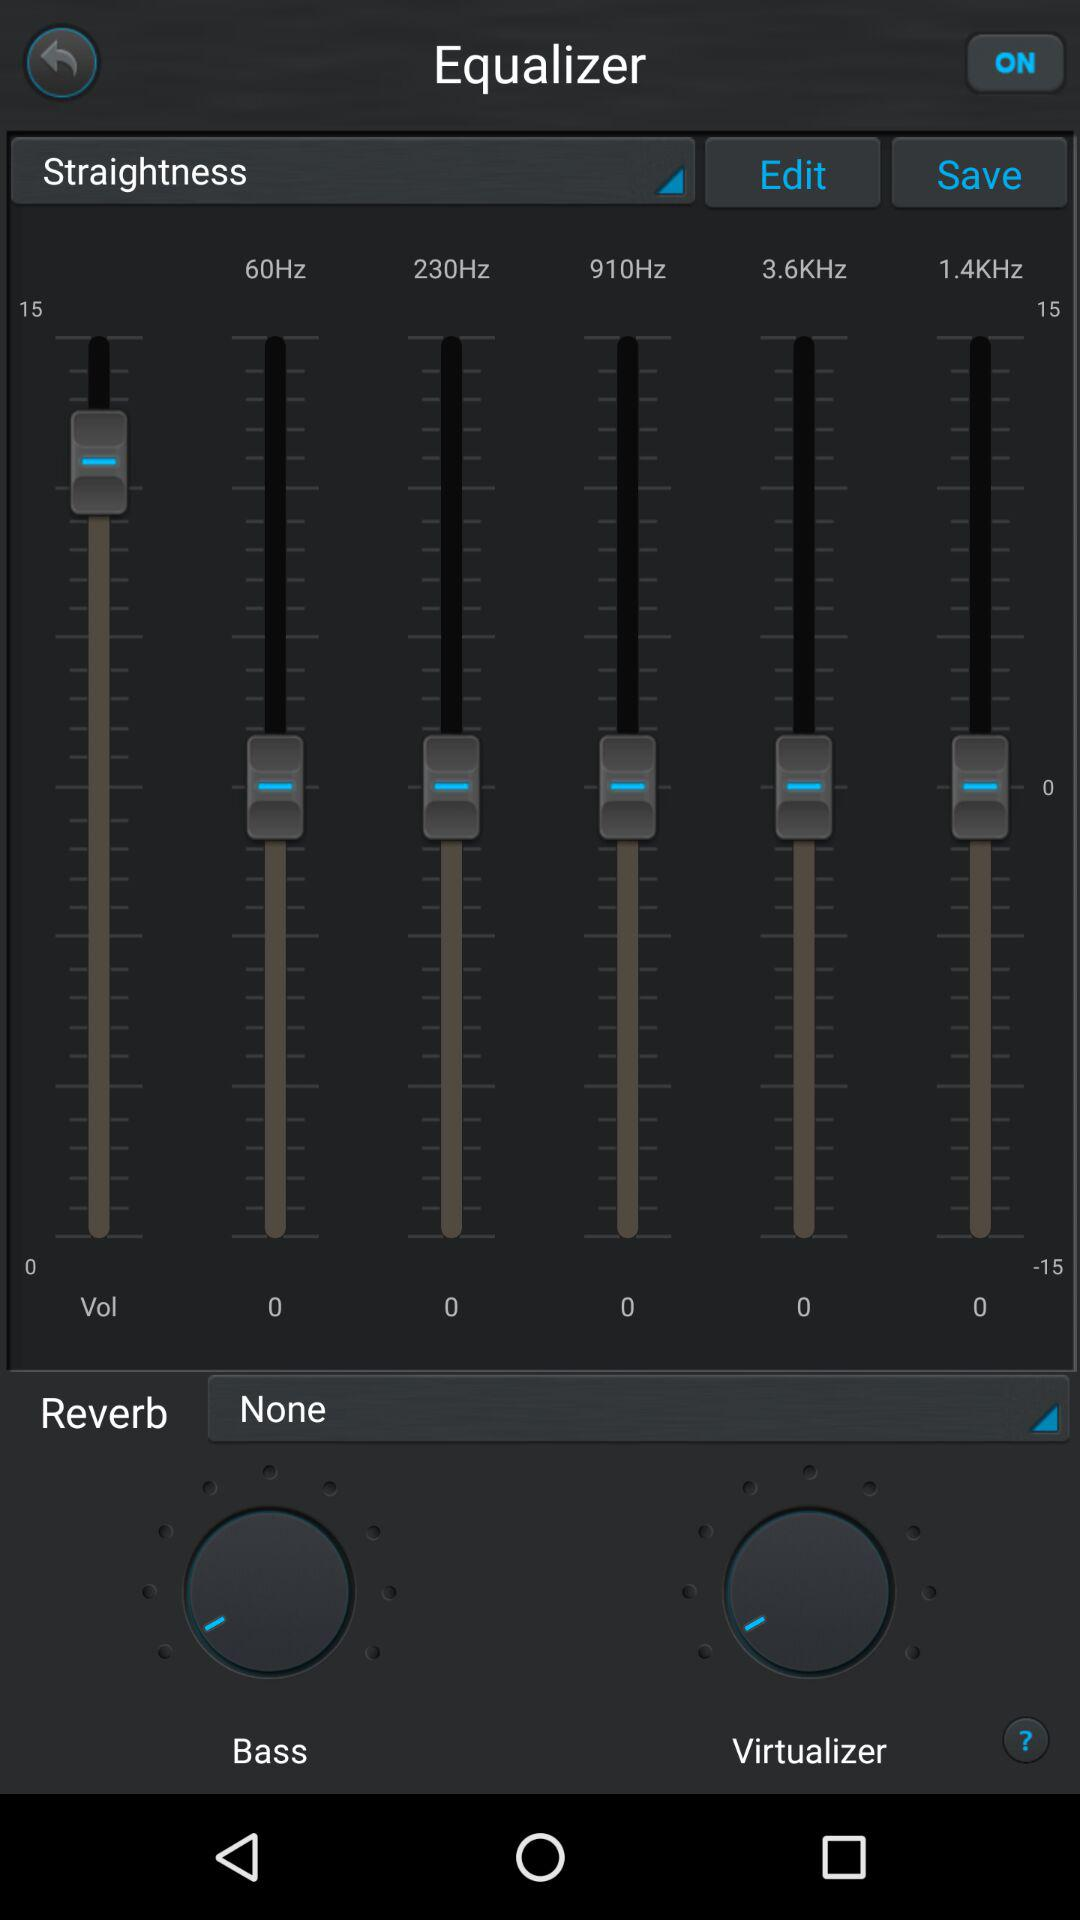What is the status of the equalizer? The status is "ON". 